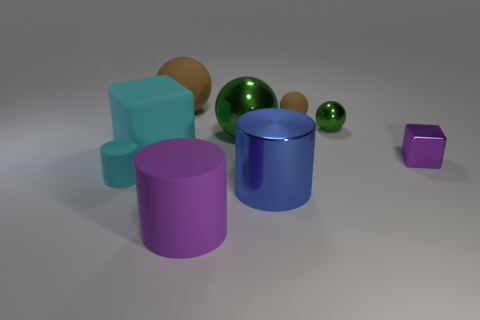Subtract 1 balls. How many balls are left? 3 Subtract all cubes. How many objects are left? 7 Subtract all large brown metal cubes. Subtract all large green objects. How many objects are left? 8 Add 9 big cyan rubber things. How many big cyan rubber things are left? 10 Add 3 tiny matte objects. How many tiny matte objects exist? 5 Subtract 0 purple balls. How many objects are left? 9 